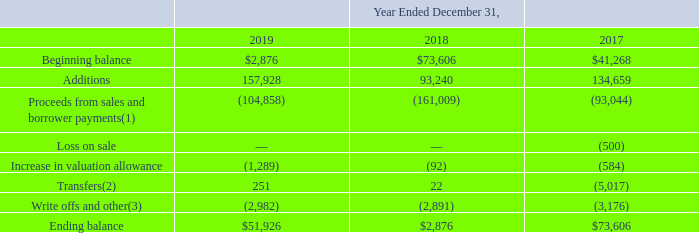GreenSky, Inc.
NOTES TO CONSOLIDATED FINANCIAL STATEMENTS — (Continued)
(United States Dollars in thousands, except per share data, unless otherwise stated)
Note 4. Loan Receivables Held for Sale
The following table summarizes the activity in the balance of loan receivables held for sale, net at lower of cost or fair value during the periods indicated.
(1) Includes accrued interest and fees, recoveries of previously charged-off loan receivables held for sale, as well as proceeds from transferring our rights to Charged-Off Receivables attributable to loan receivables held for sale. We retain servicing arrangements on sold loan receivables with the same terms and conditions as loans that are originated by our Bank Partners. Income from loan receivables held for sale activities is recorded within interest income and other gains (losses), net in the Consolidated Statements of Operations. We sold loan receivables held for sale to certain Bank Partners on the following dates during the years ended December 31:
(2) We temporarily hold certain loan receivables, which are originated by a Bank Partner, while non-originating Bank Partner eligibility is being determined. Once we determine that a loan receivable meets the investment requirements of an eligible Bank Partner, we transfer the loan receivable to the Bank Partner at cost plus any accrued interest. The reported amount also includes loan receivables that have been placed on non-accrual and non-payment status while we investigate consumer inquiries.
(3) We received recovery payments of $50, $57 and $238 during the years ended December 31, 2019, 2018 and 2017, respectively. Recoveries of principal and finance charges and fees on previously written off loan receivables held for sale are recognized on a collected basis as other gains and interest income, respectively, in the Consolidated Statements of Operations. Separately, during the years ended December 31, 2019, 2018, and 2017, write offs and other were reduced by $312, $431, and $406, respectively, related to cash proceeds received from transferring our rights to Charged-Off Receivables attributable to loan receivables held for sale. The cash proceeds received were recorded within other gains (losses), net in the Consolidated Statements of Operations.
Which years does the table show? 2019, 2018, 2017. What were the additions in 2018?
Answer scale should be: thousand. 93,240. What was the loss on sale in 2017?
Answer scale should be: thousand. (500). How many years did additions exceed $100,000 thousand? 2019##2017
Answer: 2. What was the change in the ending balance between 2017 and 2019?
Answer scale should be: thousand. 51,926-73,606
Answer: -21680. What was the percentage change in the Write offs and other between 2018 and 2019?
Answer scale should be: percent. (-2,982-(-2,891))/-2,891
Answer: 0.03. 